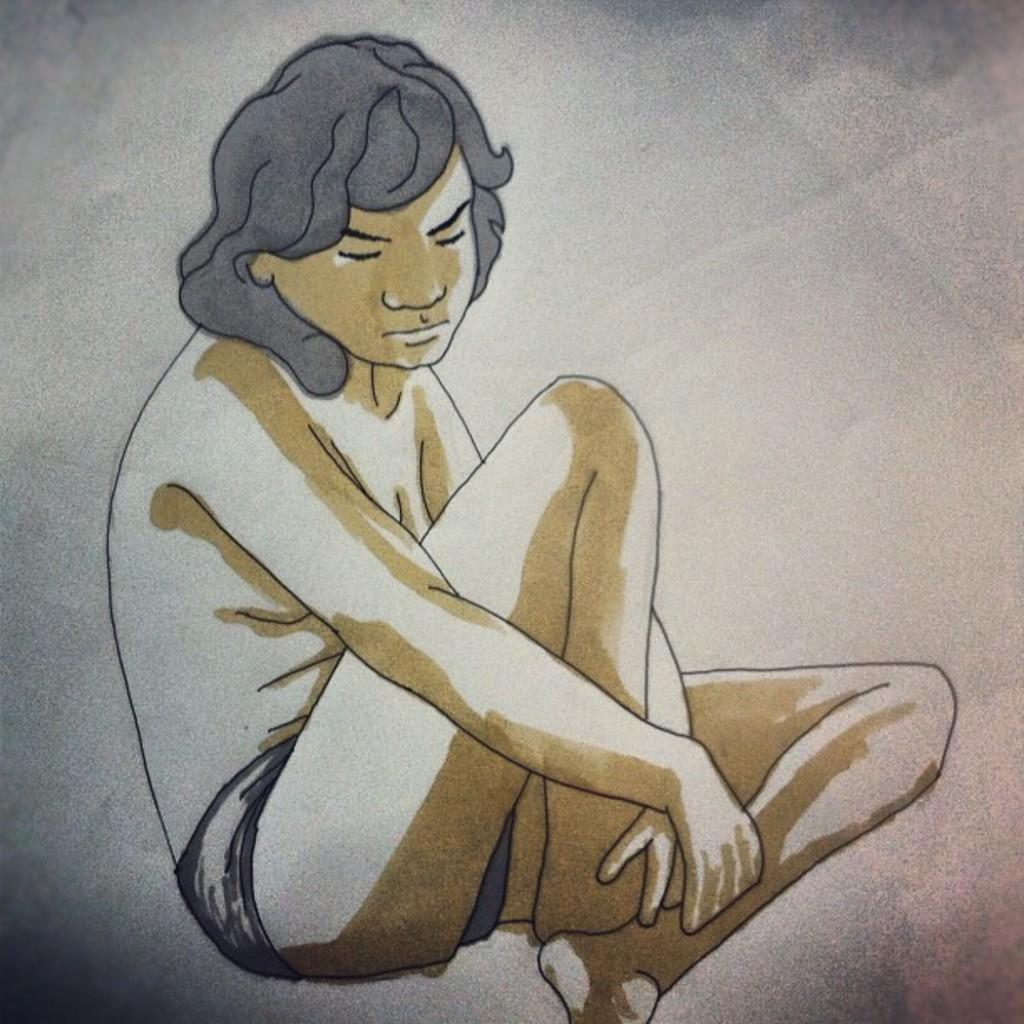What is the main subject of the image? There is a painting in the image. What does the painting depict? The painting depicts a person. How many bees can be seen buzzing around the person in the painting? There are no bees present in the image; the painting depicts a person without any bees. What type of creature is standing next to the person in the painting? There is no creature standing next to the person in the painting; the painting only depicts a person. 